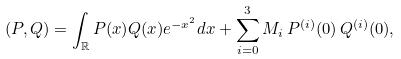<formula> <loc_0><loc_0><loc_500><loc_500>( P , Q ) = \int _ { \mathbb { R } } P ( x ) Q ( x ) e ^ { - x ^ { 2 } } d x + \sum _ { i = 0 } ^ { 3 } M _ { i } \, P ^ { ( i ) } ( 0 ) \, Q ^ { ( i ) } ( 0 ) ,</formula> 